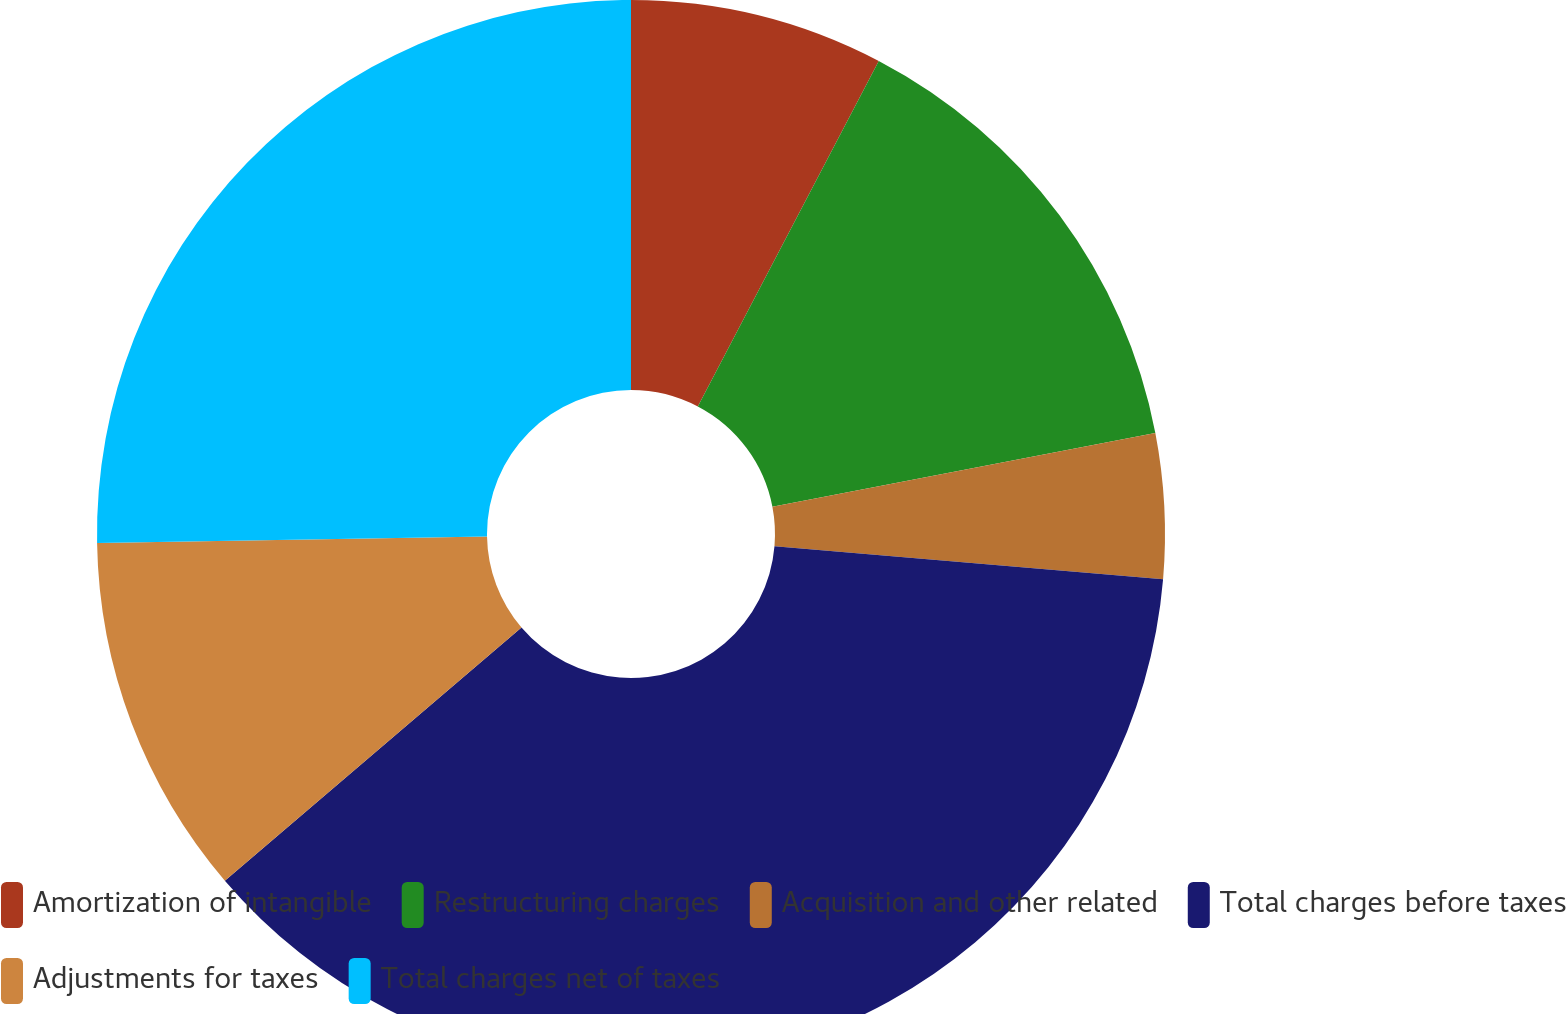Convert chart to OTSL. <chart><loc_0><loc_0><loc_500><loc_500><pie_chart><fcel>Amortization of intangible<fcel>Restructuring charges<fcel>Acquisition and other related<fcel>Total charges before taxes<fcel>Adjustments for taxes<fcel>Total charges net of taxes<nl><fcel>7.68%<fcel>14.29%<fcel>4.38%<fcel>37.41%<fcel>10.98%<fcel>25.27%<nl></chart> 